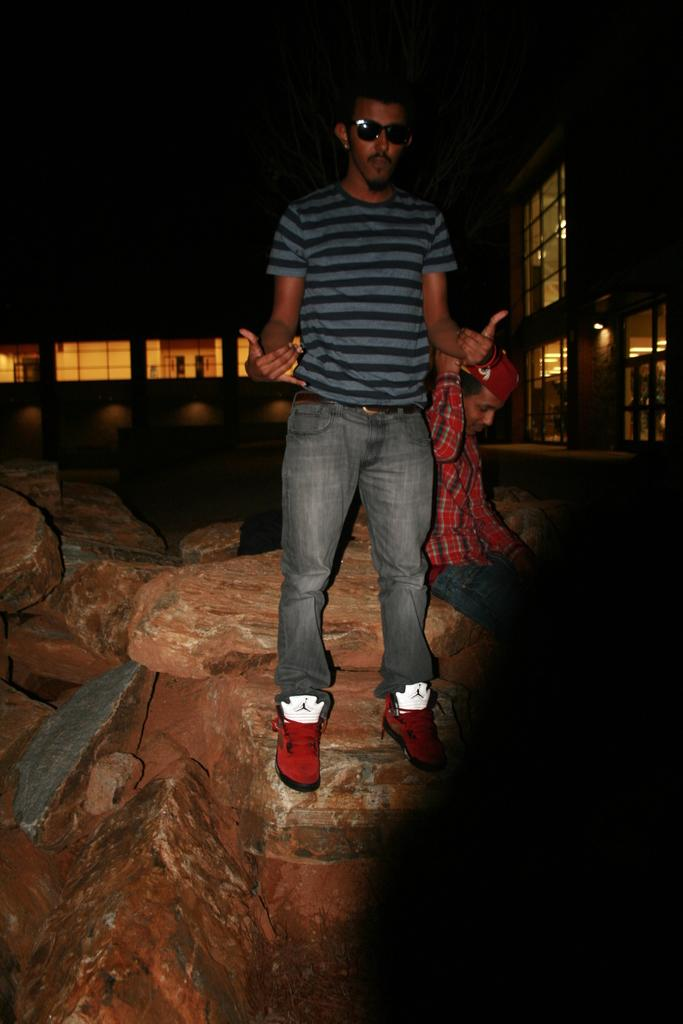What is the person in the image doing? There is a person standing on the rocks in the image. Can you describe the position of the second person in the image? There is another person sitting behind the standing person. What can be seen in the distance in the image? There are buildings and lights in the background of the image. How many cars are being pushed by the person standing on the rocks? There are no cars present in the image, so it is not possible to determine how many cars are being pushed. 